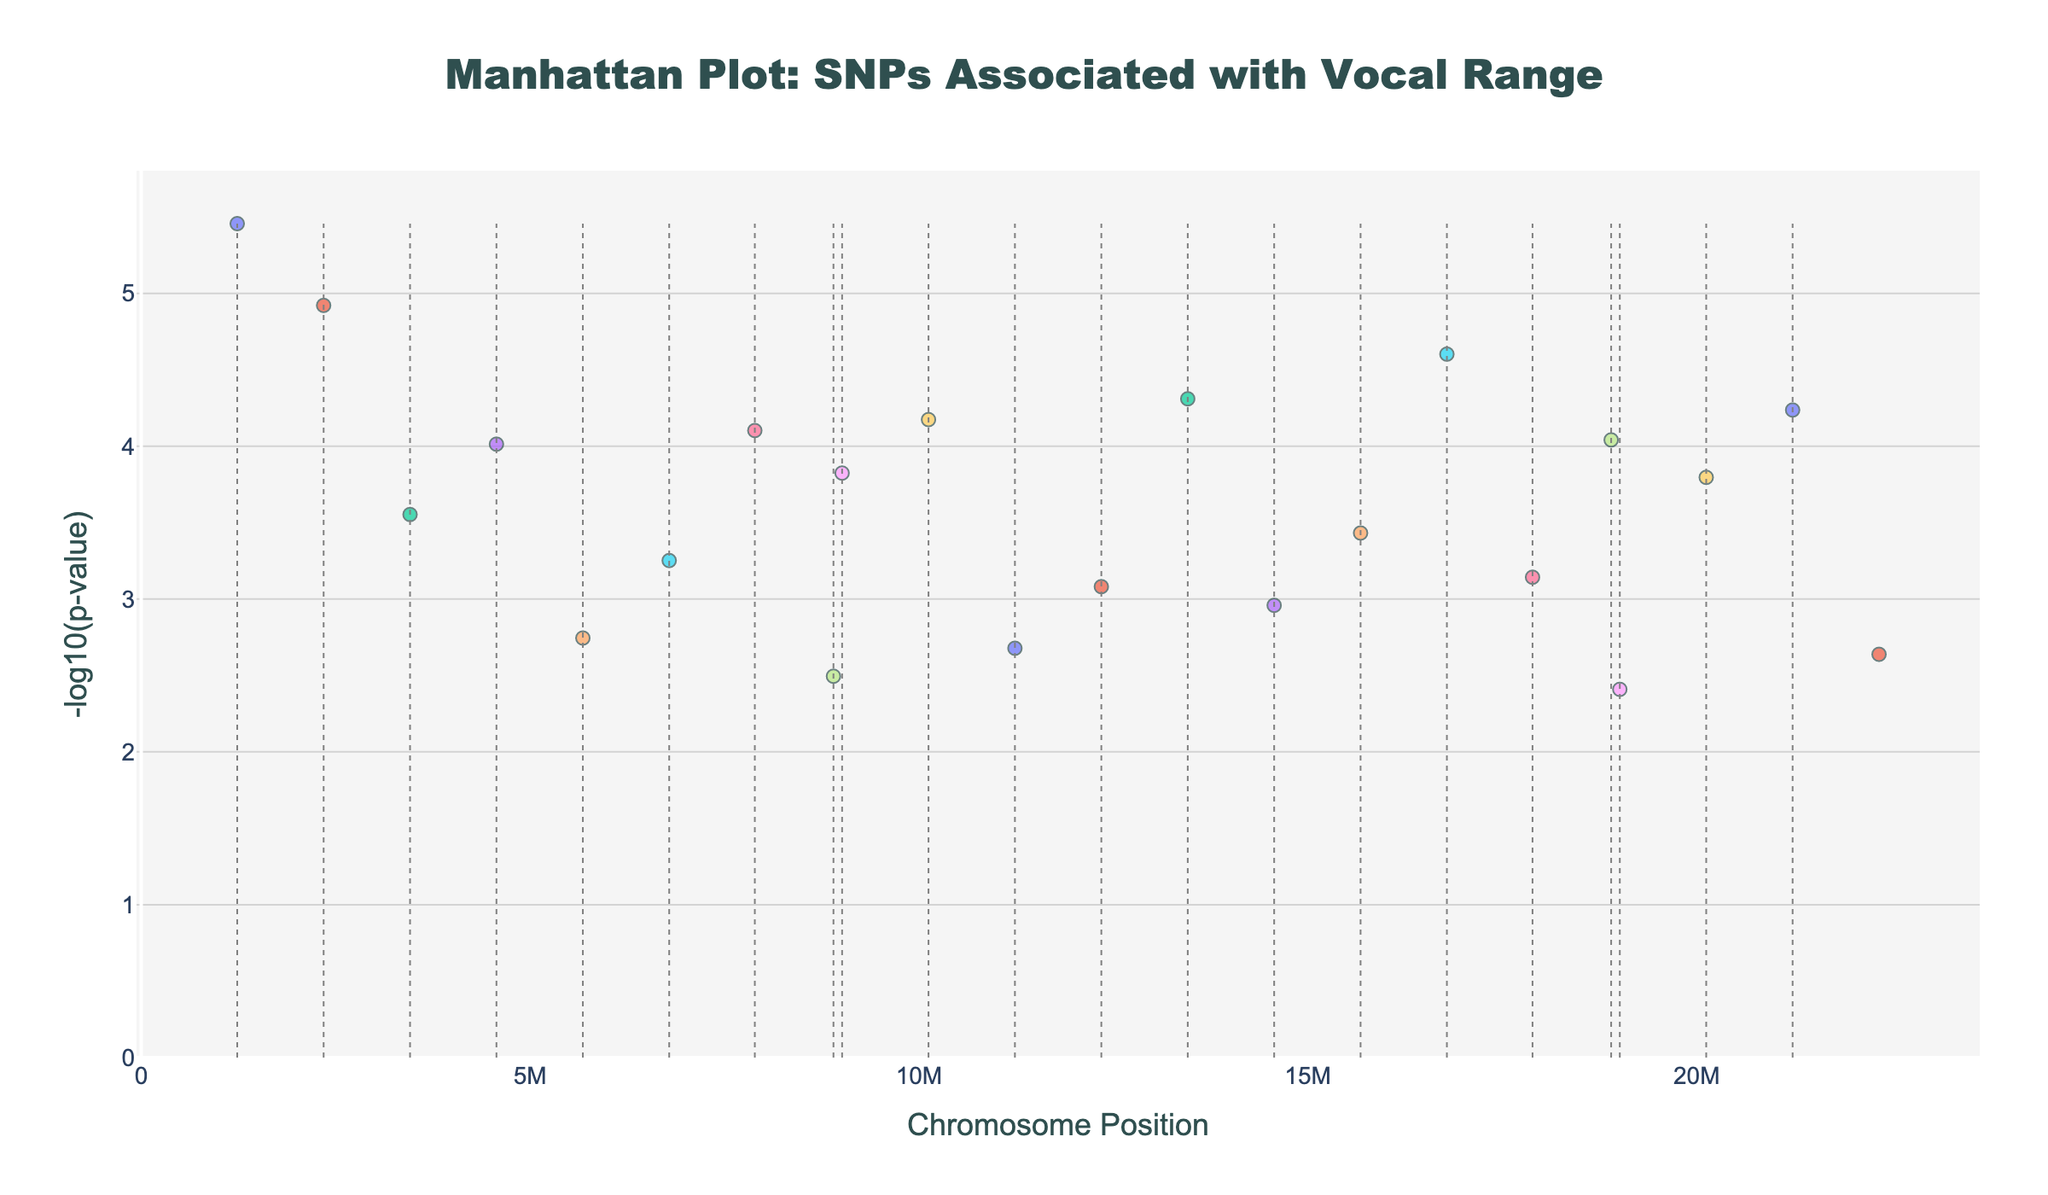What's the title of the plot? The title is usually displayed at the top-center of the figure. In this case, it's explicitly provided in the code as "Manhattan Plot: SNPs Associated with Vocal Range."
Answer: Manhattan Plot: SNPs Associated with Vocal Range What does the y-axis represent? The y-axis title is usually labeled along the y-axis. Here it shows "-log10(p-value)", which indicates the negative base-10 logarithm of the p-values for the SNPs.
Answer: -log10(p-value) Which chromosome has the highest -log10(p-value) for an SNP and what is the SNP? The highest -log10(p-value) can be found by identifying the tallest point on the plot. According to the data, chromosome 16 with SNP rs6323 has the highest -log10(p) value.
Answer: Chromosome 16, rs6323 How many SNPs are listed for chromosome 8? One can count the number of points (data entries) associated with chromosome 8 on the plot. According to the provided data, chromosome 8 has one SNP, rs10830963.
Answer: 1 Which SNPs are associated with the gene BDNF, and on which chromosomes are they located? This involves finding all the entries where the gene is BDNF and noting the corresponding SNP and chromosome. The SNPs rs6265 are on chromosomes 4 and 20.
Answer: rs6265 on chromosomes 4 and 20 What is the smallest p-value in the data, and which corresponding gene is it associated with? The smallest p-value corresponds to the highest -log10(p). By converting -log10(p) back to p-value, the smallest p-value is for SNP rs6323 related to the gene MAOA on chromosome 16.
Answer: 2.5e-5, MAOA Which gene appears most frequently among all SNPs in the plot? This requires counting the occurrences of each gene and identifying the most frequent one. The gene OXTR appears three times in the figure.
Answer: OXTR How many chromosomes have SNPs with a -log10(p-value) greater than 4? Identify from the plot which points have a -log10(p) value greater than 4 and count their corresponding chromosomes. The chromosomes are 1, 16, and 21 (3 chromosomes).
Answer: 3 Compare the -log10(p-value) of SNPs rs9935031 and rs4680. Which one has a higher value? Locate both SNPs on the plot and compare their y-axis values. rs9935031 has a -log10(p) value higher than rs4680, implying it is more statistically significant.
Answer: rs9935031 What pattern is used to create the chromosome separators in the plot? The chromosome separators appear as vertical lines, and their pattern can be deduced from the description. They are grey, dotted lines positioned at the maximum position value of each chromosome.
Answer: Grey, dotted vertical lines 